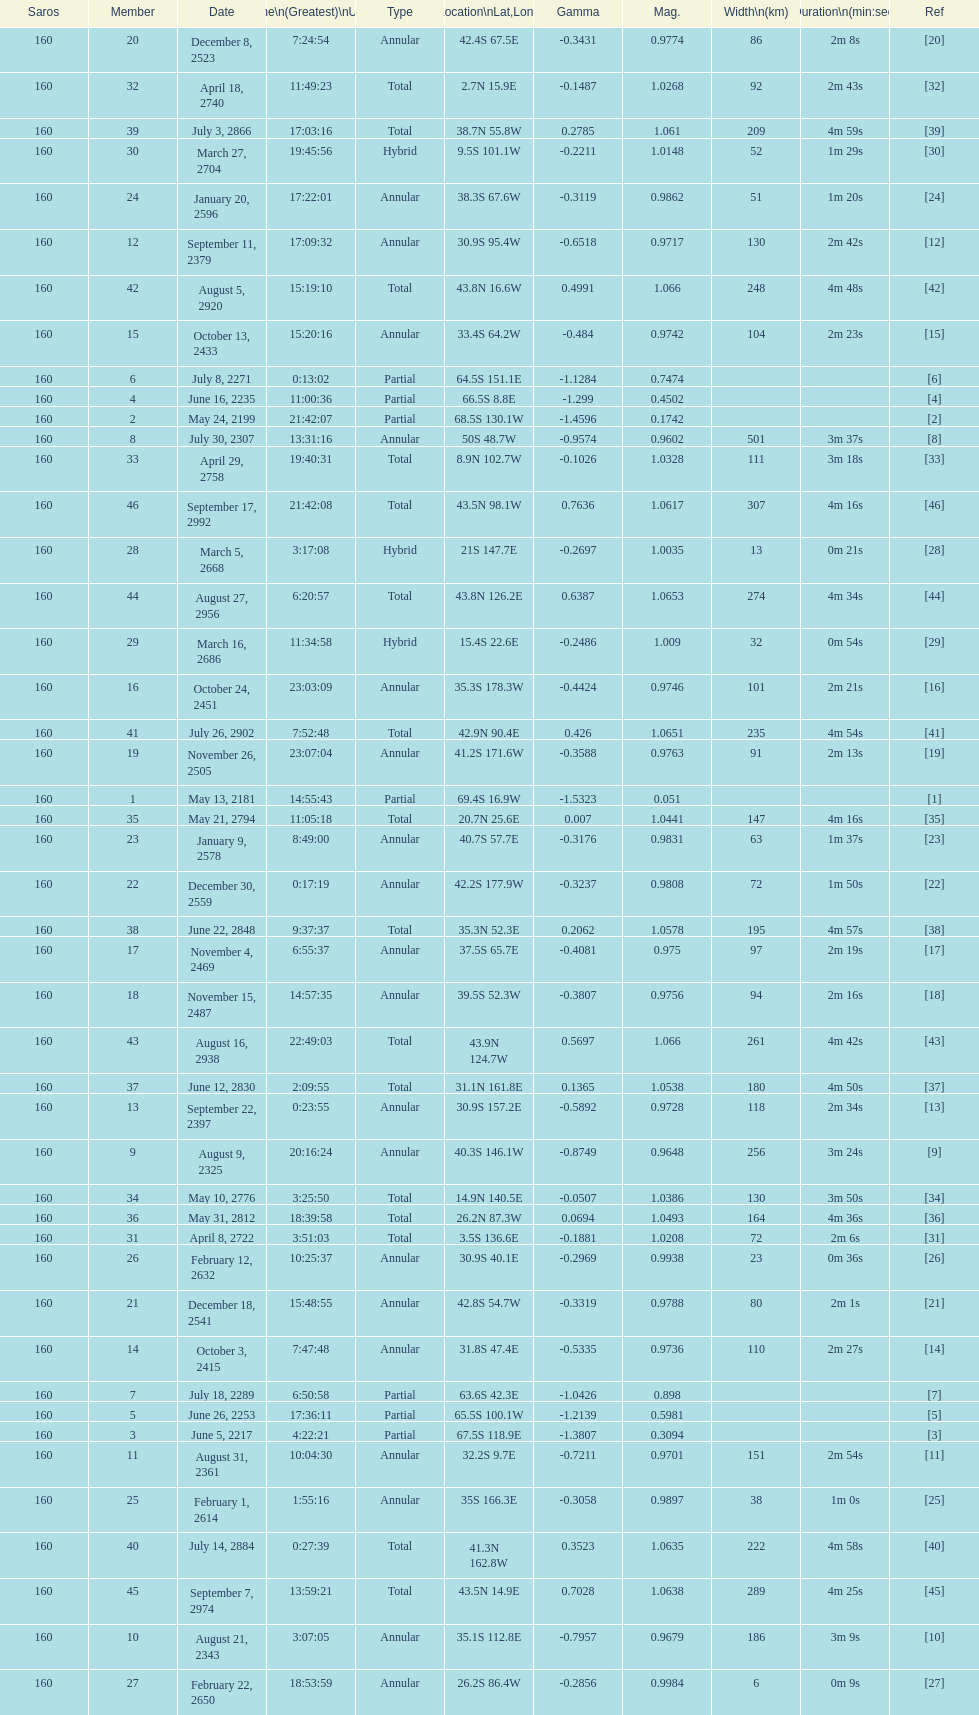How long did 18 last? 2m 16s. 